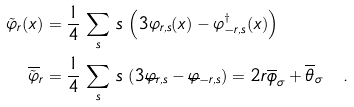<formula> <loc_0><loc_0><loc_500><loc_500>\tilde { \varphi } _ { r } ( x ) & = \frac { 1 } { 4 } \, \sum _ { s } \, s \, \left ( { 3 } \varphi _ { r , s } ( x ) - \varphi _ { - r , s } ^ { \dagger } ( x ) \right ) \, \\ { \overline { \tilde { \varphi } } } _ { r } & = \frac { 1 } { 4 } \, \sum _ { s } \, s \, \left ( { 3 } \overline { \varphi } _ { r , s } - \overline { \varphi } _ { - r , s } \right ) = 2 r \overline { \phi } _ { \sigma } + \overline { \theta } _ { \sigma } \quad .</formula> 